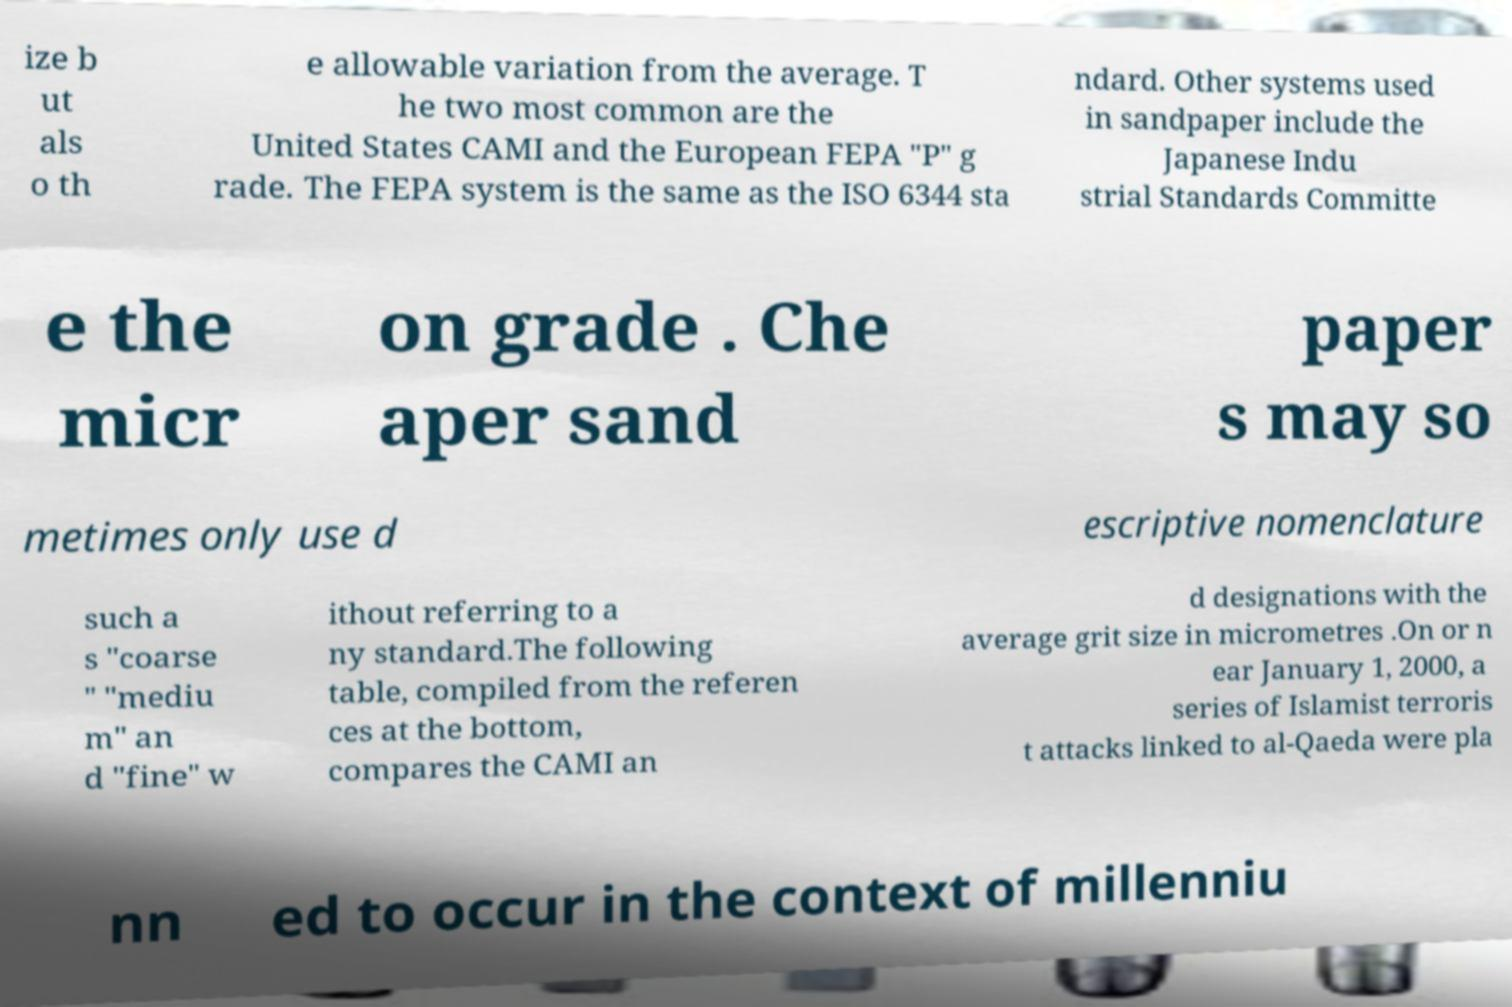For documentation purposes, I need the text within this image transcribed. Could you provide that? ize b ut als o th e allowable variation from the average. T he two most common are the United States CAMI and the European FEPA "P" g rade. The FEPA system is the same as the ISO 6344 sta ndard. Other systems used in sandpaper include the Japanese Indu strial Standards Committe e the micr on grade . Che aper sand paper s may so metimes only use d escriptive nomenclature such a s "coarse " "mediu m" an d "fine" w ithout referring to a ny standard.The following table, compiled from the referen ces at the bottom, compares the CAMI an d designations with the average grit size in micrometres .On or n ear January 1, 2000, a series of Islamist terroris t attacks linked to al-Qaeda were pla nn ed to occur in the context of millenniu 